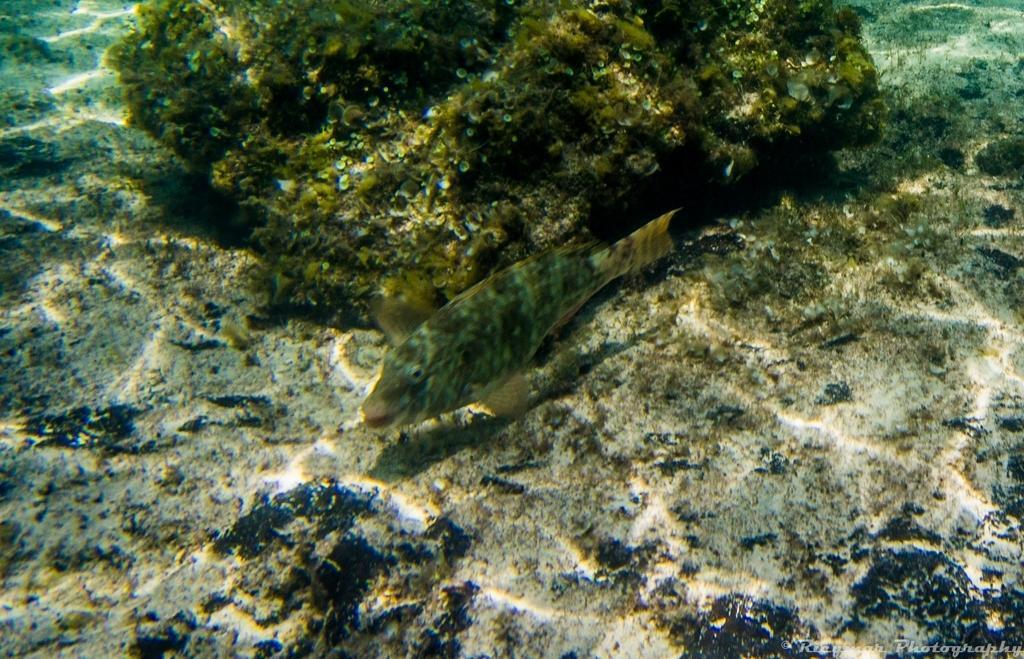Could you give a brief overview of what you see in this image? In water there is a fish and corals. 